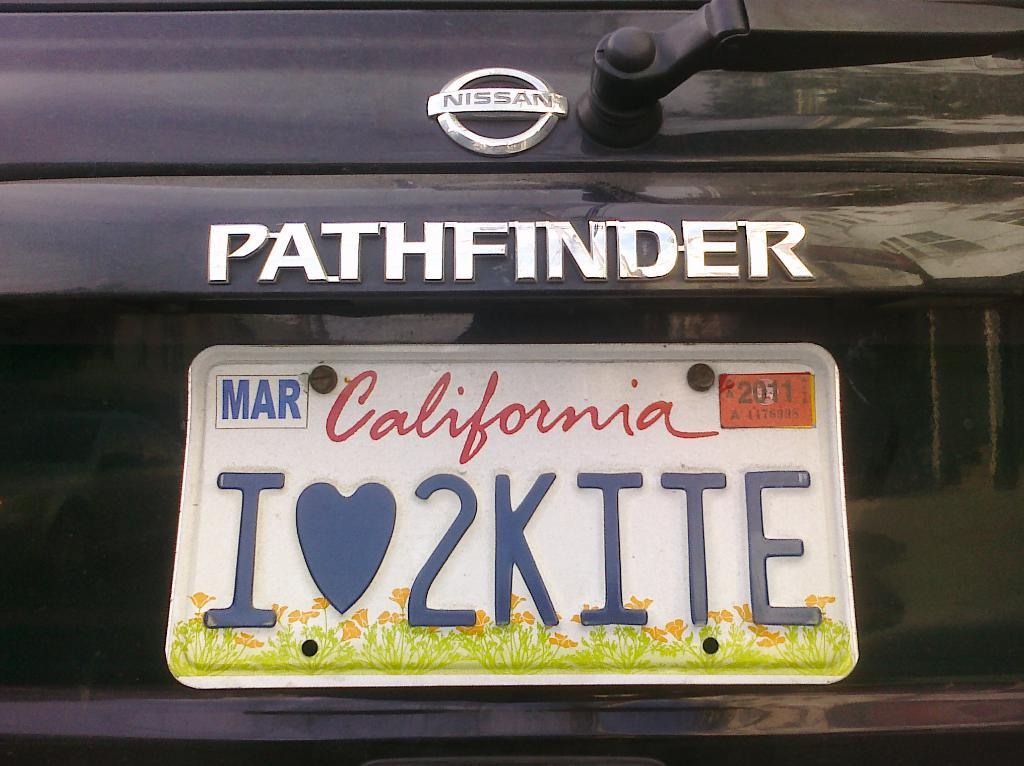<image>
Offer a succinct explanation of the picture presented. The back of a black nissan branded pathfinder with a california license plate. 